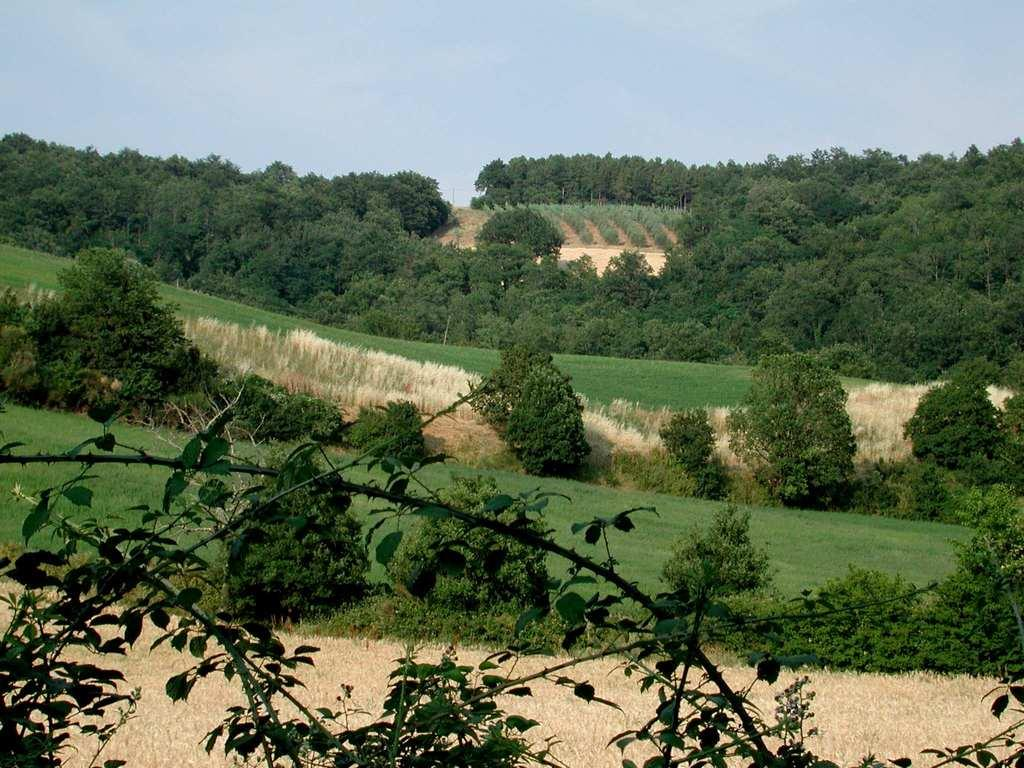What type of vegetation is present in the image? There are many trees in the image. What is the ground covered with in the image? The image consists of grass. What is visible at the top of the image? The sky is visible at the top of the image. How many bubbles can be seen floating in the image? There are no bubbles present in the image; it features trees, grass, and the sky. What type of maid is depicted in the image? There is no maid present in the image. 